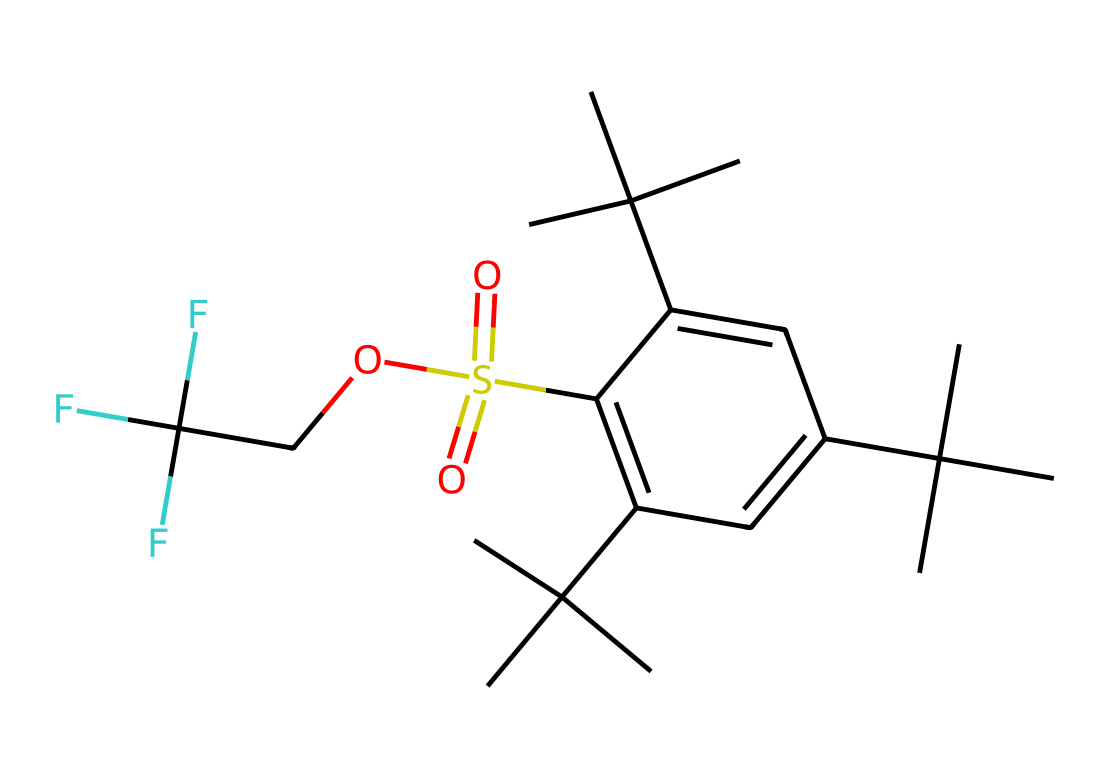what is the total number of carbon atoms in this compound? By examining the SMILES representation, we can identify the number of carbon (C) symbols present. Counting through the structure, we find a total of 18 carbon atoms.
Answer: 18 how many oxygen atoms are in the chemical structure? The SMILES notation contains the letter 'O' multiple times. Counting the occurrences of 'O' gives us 3 oxygen atoms in the structure.
Answer: 3 what does the presence of S(=O)(=O) indicate about this compound? The presence of S(=O)(=O) shows that there is a sulfur atom bonded to two oxygen atoms with double bonds, indicating that this compound features a hypervalent sulfur center in a sulfonic acid group.
Answer: hypervalent sulfur what is the main functional group in this chemical? The SMILES notation indicates the presence of -SO3H (sulfonic acid) due to the S(=O)(=O)O part of the structure. This functional group is crucial for the chemical's properties as a diesel fuel additive.
Answer: sulfonic acid how does the structure of this compound suggest its potential use as a diesel fuel additive? The presence of hypervalent sulfur in a sulfonic acid group (S(=O)(=O)O) alongside other hydrocarbon chains indicates that it may assist in improving fuel quality and combustion efficiency, reducing emissions.
Answer: improves combustion efficiency 